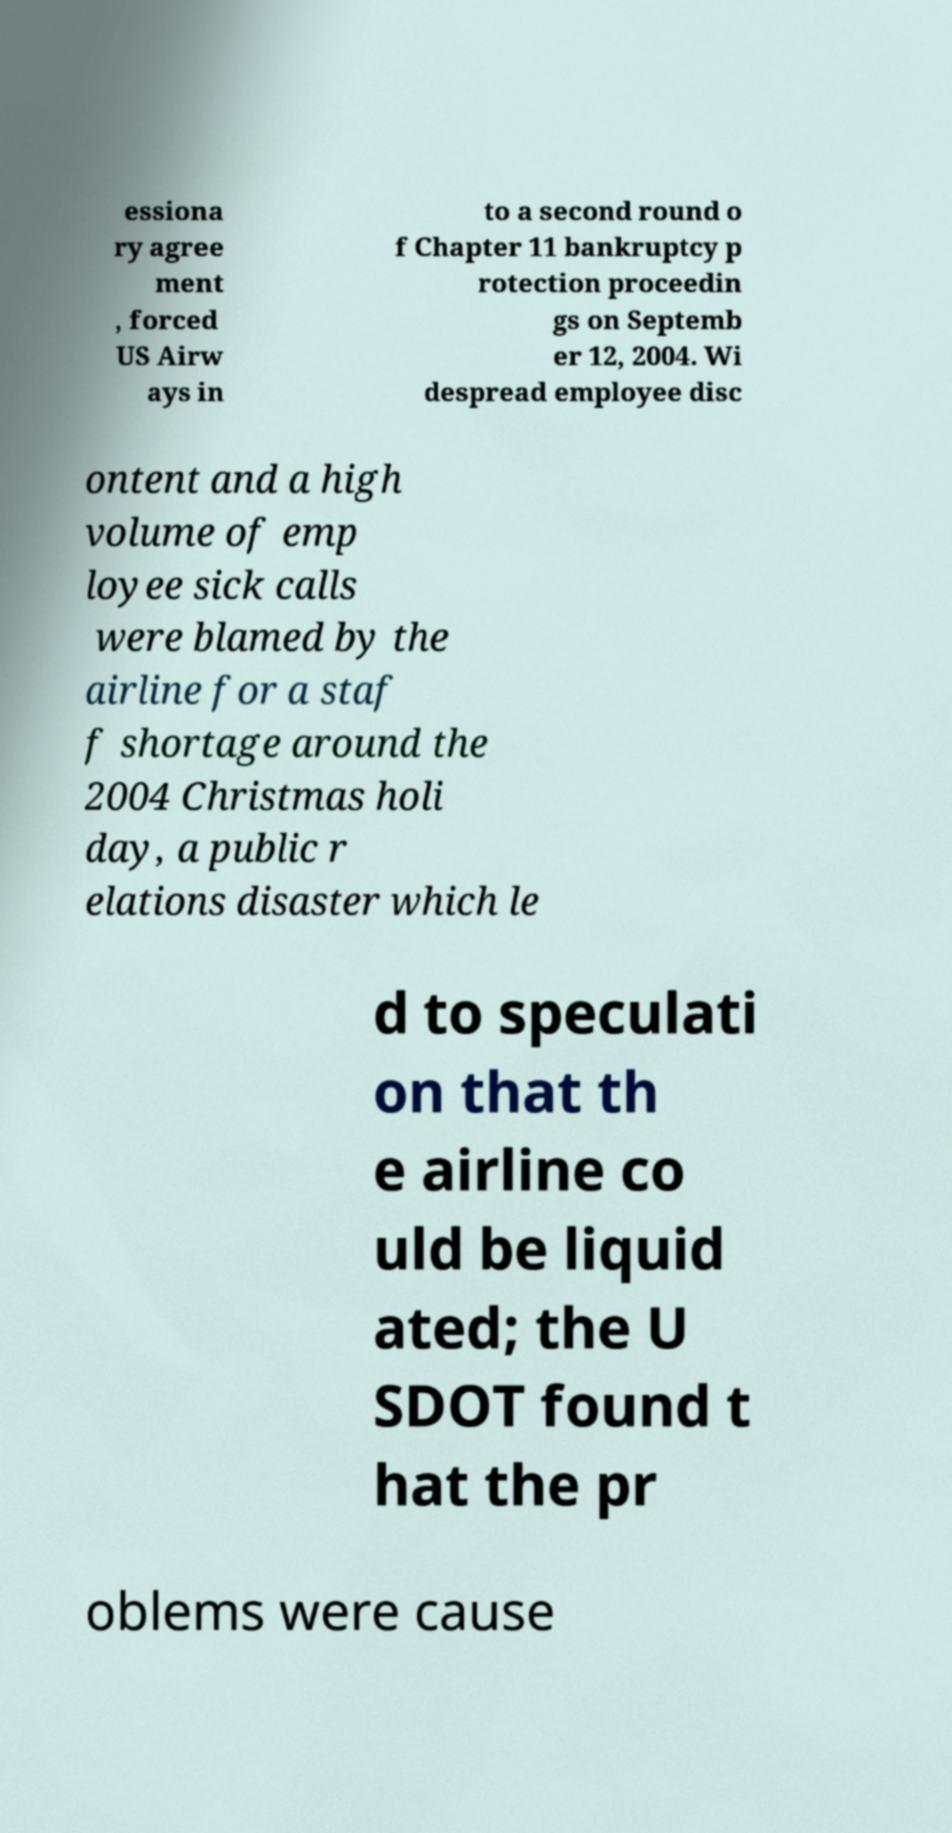Could you extract and type out the text from this image? essiona ry agree ment , forced US Airw ays in to a second round o f Chapter 11 bankruptcy p rotection proceedin gs on Septemb er 12, 2004. Wi despread employee disc ontent and a high volume of emp loyee sick calls were blamed by the airline for a staf f shortage around the 2004 Christmas holi day, a public r elations disaster which le d to speculati on that th e airline co uld be liquid ated; the U SDOT found t hat the pr oblems were cause 